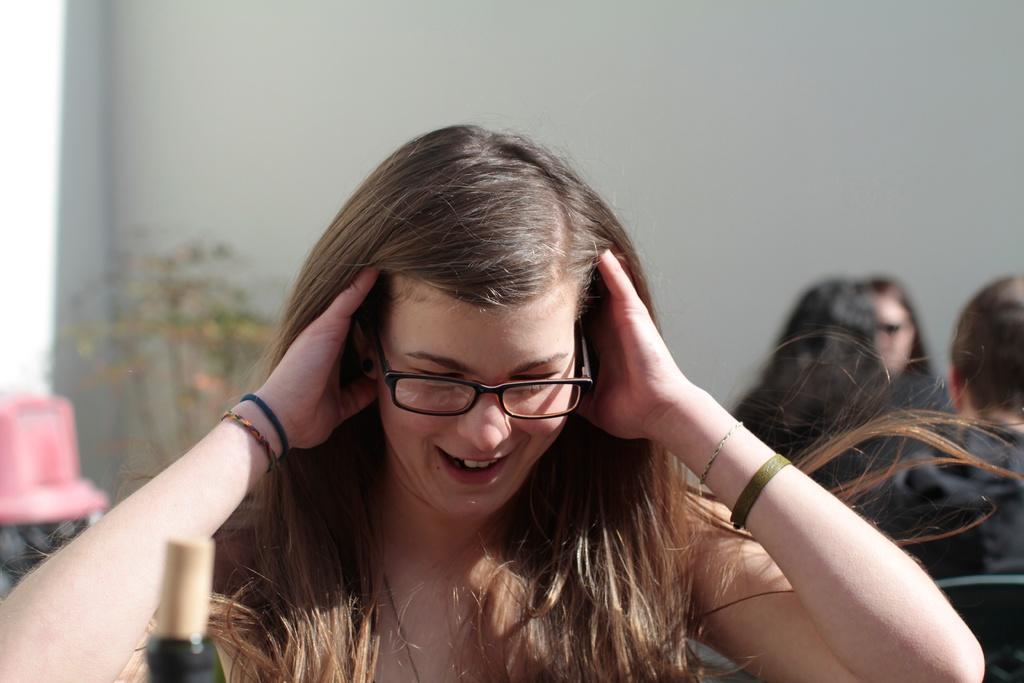Can you describe this image briefly? In this image we can see a few people sitting, on the left side of the image we can see a pink color object and a plant, in the background we can see a wall. 